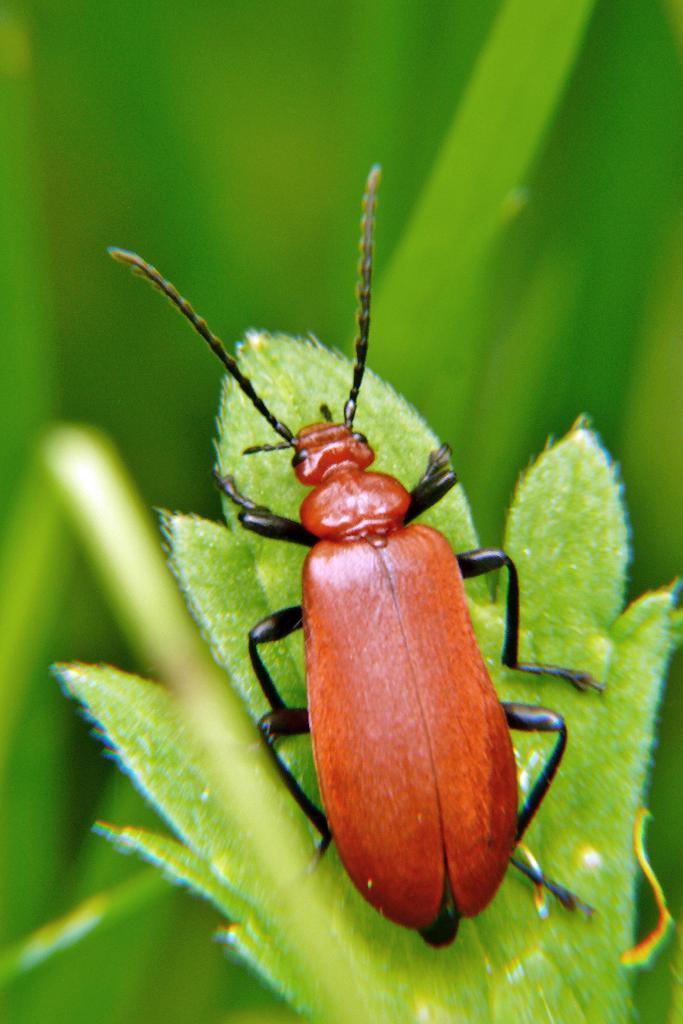Could you give a brief overview of what you see in this image? In this picture we can see an insect on a green leaf. Background is blurry. 